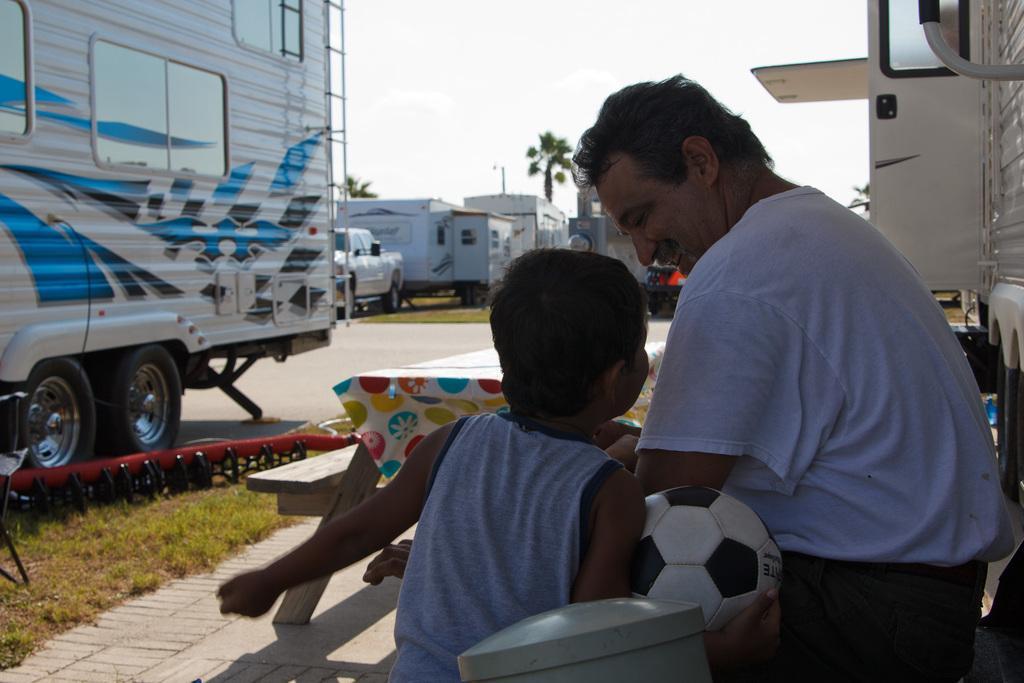Could you give a brief overview of what you see in this image? In this picture we can see two people sitting on the chair a small boy holding a ball in front of them there is a vehicle. 